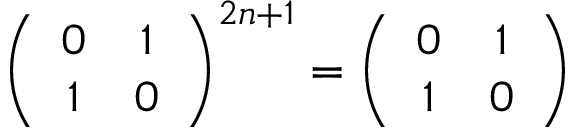<formula> <loc_0><loc_0><loc_500><loc_500>\left ( \begin{array} { c c } { 0 } & { 1 } \\ { 1 } & { 0 } \end{array} \right ) ^ { 2 n + 1 } = \left ( \begin{array} { c c } { 0 } & { 1 } \\ { 1 } & { 0 } \end{array} \right )</formula> 